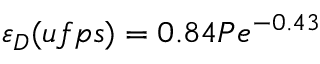<formula> <loc_0><loc_0><loc_500><loc_500>\varepsilon _ { D } ( u f p s ) = 0 . 8 4 P e ^ { - 0 . 4 3 }</formula> 